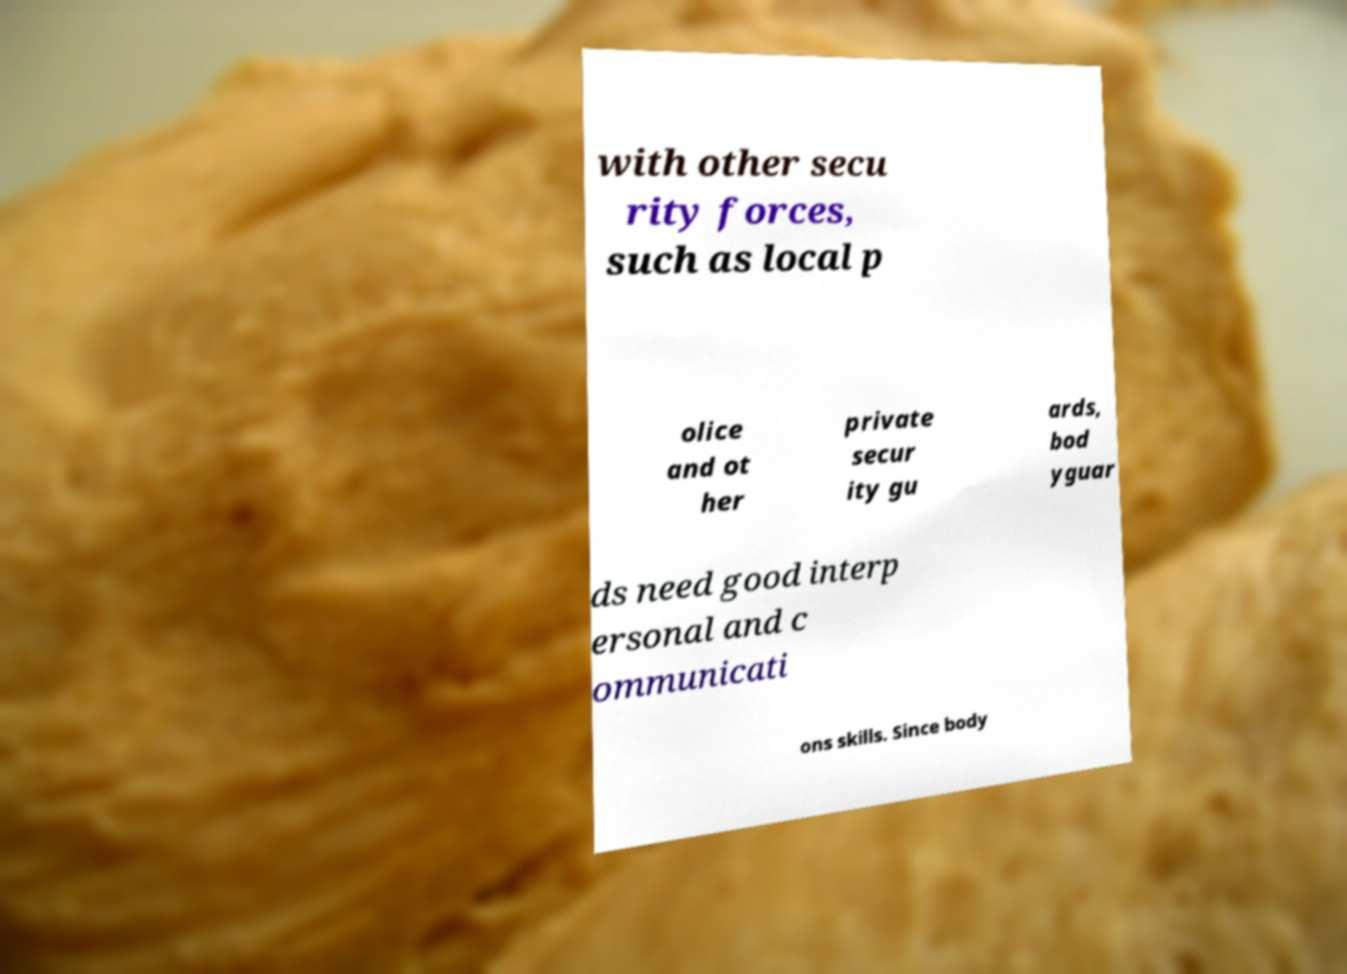Could you extract and type out the text from this image? with other secu rity forces, such as local p olice and ot her private secur ity gu ards, bod yguar ds need good interp ersonal and c ommunicati ons skills. Since body 